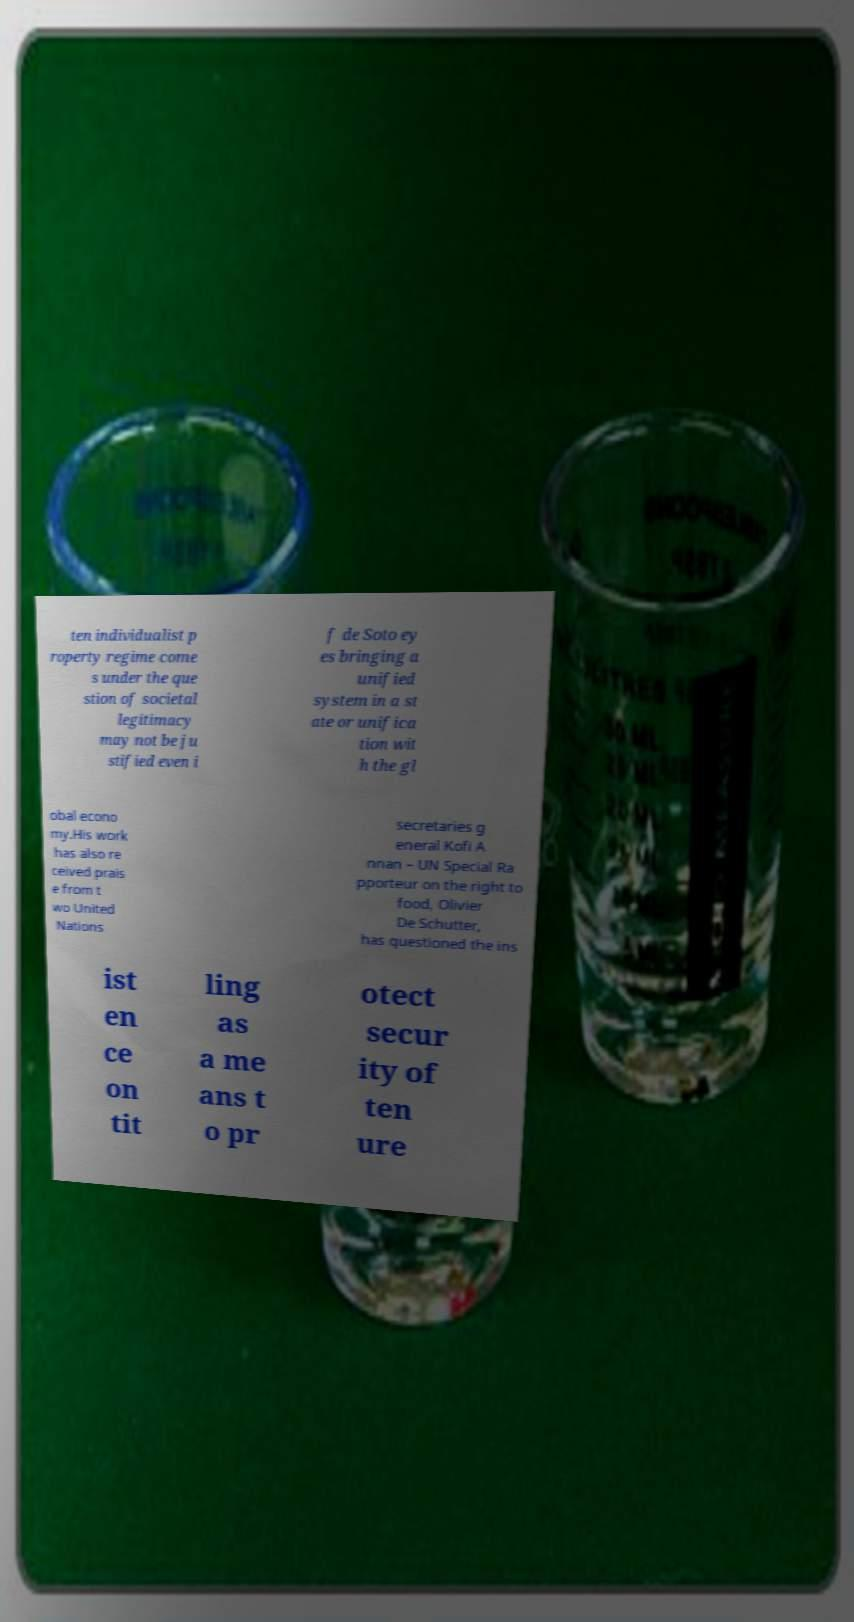Can you read and provide the text displayed in the image?This photo seems to have some interesting text. Can you extract and type it out for me? ten individualist p roperty regime come s under the que stion of societal legitimacy may not be ju stified even i f de Soto ey es bringing a unified system in a st ate or unifica tion wit h the gl obal econo my.His work has also re ceived prais e from t wo United Nations secretaries g eneral Kofi A nnan – UN Special Ra pporteur on the right to food, Olivier De Schutter, has questioned the ins ist en ce on tit ling as a me ans t o pr otect secur ity of ten ure 